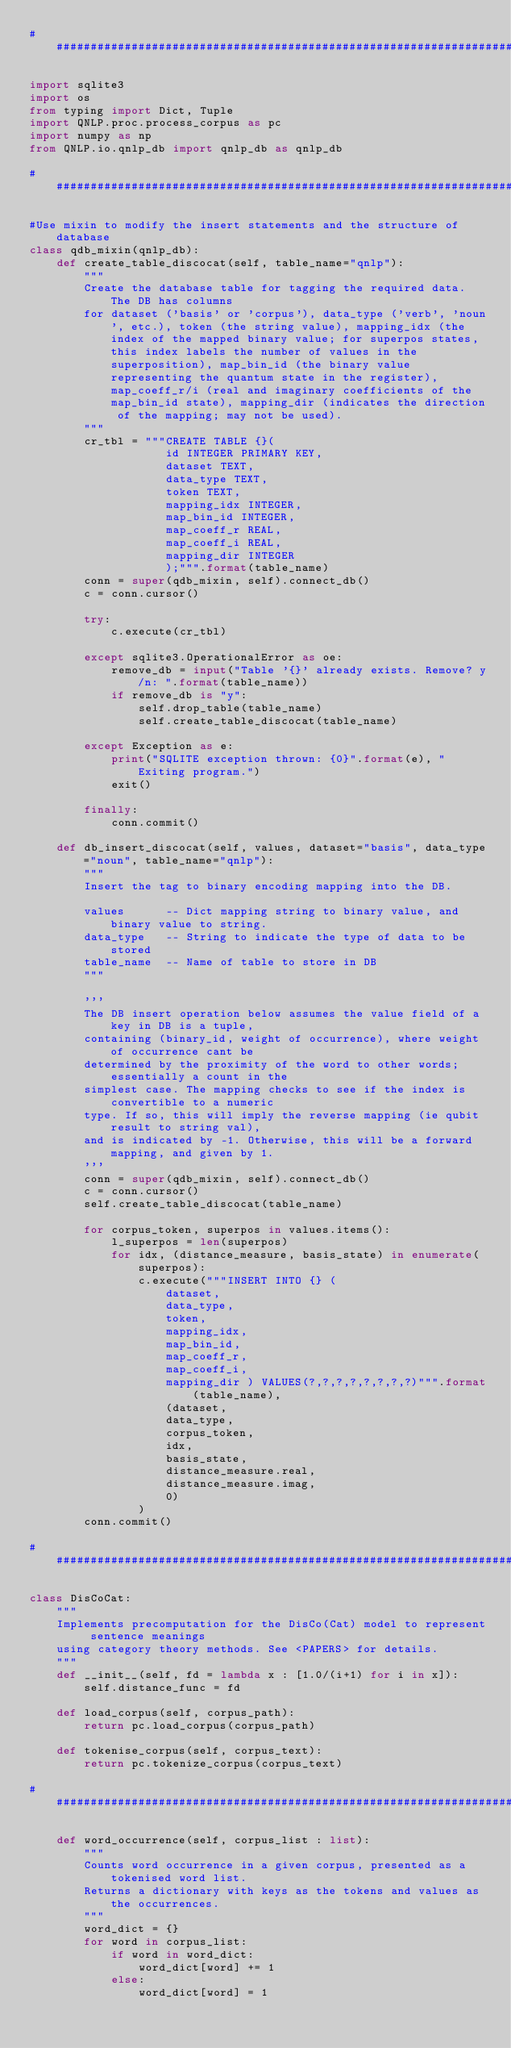<code> <loc_0><loc_0><loc_500><loc_500><_Python_>###############################################################################

import sqlite3
import os
from typing import Dict, Tuple
import QNLP.proc.process_corpus as pc
import numpy as np
from QNLP.io.qnlp_db import qnlp_db as qnlp_db

###############################################################################

#Use mixin to modify the insert statements and the structure of database
class qdb_mixin(qnlp_db):
    def create_table_discocat(self, table_name="qnlp"):
        """
        Create the database table for tagging the required data. The DB has columns
        for dataset ('basis' or 'corpus'), data_type ('verb', 'noun', etc.), token (the string value), mapping_idx (the index of the mapped binary value; for superpos states, this index labels the number of values in the superposition), map_bin_id (the binary value representing the quantum state in the register), map_coeff_r/i (real and imaginary coefficients of the map_bin_id state), mapping_dir (indicates the direction of the mapping; may not be used).
        """
        cr_tbl = """CREATE TABLE {}(
                    id INTEGER PRIMARY KEY, 
                    dataset TEXT,
                    data_type TEXT,
                    token TEXT,
                    mapping_idx INTEGER,
                    map_bin_id INTEGER,
                    map_coeff_r REAL,
                    map_coeff_i REAL,
                    mapping_dir INTEGER
                    );""".format(table_name)
        conn = super(qdb_mixin, self).connect_db()
        c = conn.cursor()

        try:
            c.execute(cr_tbl)

        except sqlite3.OperationalError as oe:
            remove_db = input("Table '{}' already exists. Remove? y/n: ".format(table_name))
            if remove_db is "y":
                self.drop_table(table_name)
                self.create_table_discocat(table_name)

        except Exception as e:
            print("SQLITE exception thrown: {0}".format(e), "Exiting program.")
            exit()

        finally:
            conn.commit()

    def db_insert_discocat(self, values, dataset="basis", data_type="noun", table_name="qnlp"):
        """
        Insert the tag to binary encoding mapping into the DB.

        values      -- Dict mapping string to binary value, and binary value to string.
        data_type   -- String to indicate the type of data to be stored
        table_name  -- Name of table to store in DB
        """

        '''
        The DB insert operation below assumes the value field of a key in DB is a tuple,
        containing (binary_id, weight of occurrence), where weight of occurrence cant be
        determined by the proximity of the word to other words; essentially a count in the 
        simplest case. The mapping checks to see if the index is convertible to a numeric
        type. If so, this will imply the reverse mapping (ie qubit result to string val), 
        and is indicated by -1. Otherwise, this will be a forward mapping, and given by 1.
        '''
        conn = super(qdb_mixin, self).connect_db()
        c = conn.cursor()
        self.create_table_discocat(table_name)
        
        for corpus_token, superpos in values.items():
            l_superpos = len(superpos)
            for idx, (distance_measure, basis_state) in enumerate(superpos):
                c.execute("""INSERT INTO {} ( 
                    dataset, 
                    data_type, 
                    token, 
                    mapping_idx, 
                    map_bin_id, 
                    map_coeff_r, 
                    map_coeff_i, 
                    mapping_dir ) VALUES(?,?,?,?,?,?,?,?)""".format(table_name), 
                    (dataset, 
                    data_type, 
                    corpus_token, 
                    idx, 
                    basis_state, 
                    distance_measure.real, 
                    distance_measure.imag, 
                    0)
                )
        conn.commit()

###############################################################################

class DisCoCat:
    """
    Implements precomputation for the DisCo(Cat) model to represent sentence meanings
    using category theory methods. See <PAPERS> for details.
    """
    def __init__(self, fd = lambda x : [1.0/(i+1) for i in x]):
        self.distance_func = fd

    def load_corpus(self, corpus_path):
        return pc.load_corpus(corpus_path)
    
    def tokenise_corpus(self, corpus_text):
        return pc.tokenize_corpus(corpus_text)

###############################################################################

    def word_occurrence(self, corpus_list : list):
        """
        Counts word occurrence in a given corpus, presented as a tokenised word list.
        Returns a dictionary with keys as the tokens and values as the occurrences.
        """
        word_dict = {}
        for word in corpus_list:
            if word in word_dict:
                word_dict[word] += 1
            else:
                word_dict[word] = 1</code> 